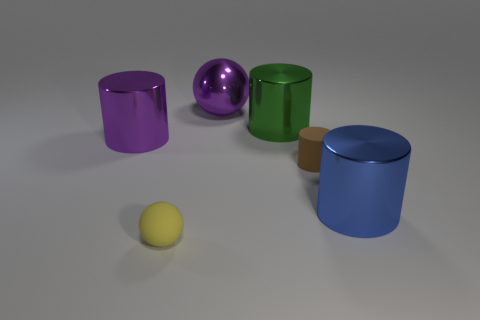Subtract all small matte cylinders. How many cylinders are left? 3 Subtract all blue cylinders. How many cylinders are left? 3 Subtract 4 cylinders. How many cylinders are left? 0 Add 5 blue cylinders. How many blue cylinders are left? 6 Add 5 gray rubber cylinders. How many gray rubber cylinders exist? 5 Add 1 blue metal things. How many objects exist? 7 Subtract 1 brown cylinders. How many objects are left? 5 Subtract all spheres. How many objects are left? 4 Subtract all cyan balls. Subtract all red cylinders. How many balls are left? 2 Subtract all red cubes. How many green cylinders are left? 1 